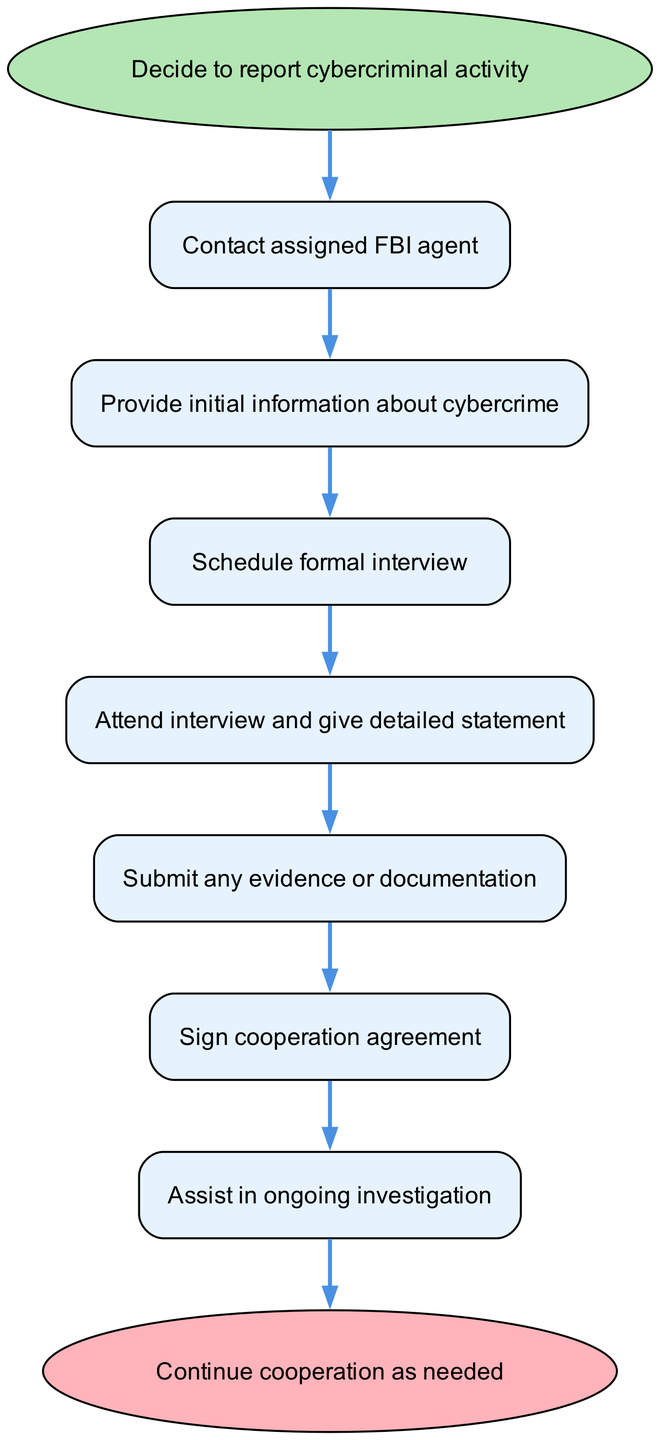What is the first step in reporting cybercriminal activity? The first step, as indicated in the diagram, is to "Decide to report cybercriminal activity." This is visually represented as the starting point of the flow chart.
Answer: Decide to report cybercriminal activity How many nodes are there in the diagram? The diagram includes a total of 8 nodes, counting the start and end nodes, as well as the steps in between. Each unique process or decision is represented as a node.
Answer: 8 What is the last action after assisting in the investigation? The last action in the flow chart following the assistance in the investigation is "Continue cooperation as needed." This indicates the ongoing relationship with law enforcement after the initial reporting process.
Answer: Continue cooperation as needed Which step follows the scheduling of a formal interview? After scheduling the formal interview, the next step is to "Attend interview and give detailed statement." This shows the progression from scheduling to participating in the interview.
Answer: Attend interview and give detailed statement What are the actions required before signing the cooperation agreement? Before signing the cooperation agreement, the actions required are to "Submit any evidence or documentation." This indicates a necessary step that must be completed beforehand.
Answer: Submit any evidence or documentation How many connections are there between the nodes? There are a total of 7 connections in the diagram. Each connection represents a direct relationship or flow from one node (step) to another, indicating the sequence of actions.
Answer: 7 What happens immediately after providing initial information about cybercrime? Immediately after providing initial information about cybercrime, the next step is to "Schedule formal interview." This shows that providing information leads directly to planning the interview.
Answer: Schedule formal interview What is the purpose of the cooperation agreement? The cooperation agreement serves to formalize the individual's commitment to assist law enforcement in the ensuing investigation after they have provided evidence and statements. This is crucial for ensuring ongoing collaboration.
Answer: Sign cooperation agreement 